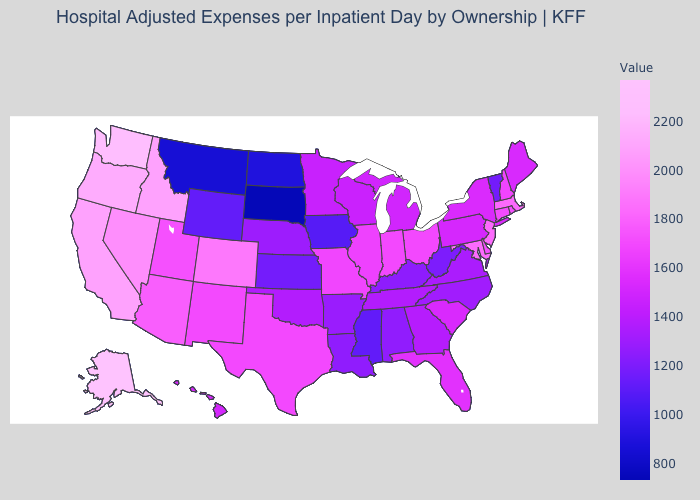Does Maine have the lowest value in the USA?
Quick response, please. No. Among the states that border Wyoming , does Utah have the lowest value?
Quick response, please. No. Among the states that border Kansas , which have the lowest value?
Concise answer only. Nebraska. Does Florida have a lower value than Idaho?
Answer briefly. Yes. Which states have the lowest value in the USA?
Concise answer only. South Dakota. Does the map have missing data?
Answer briefly. No. 